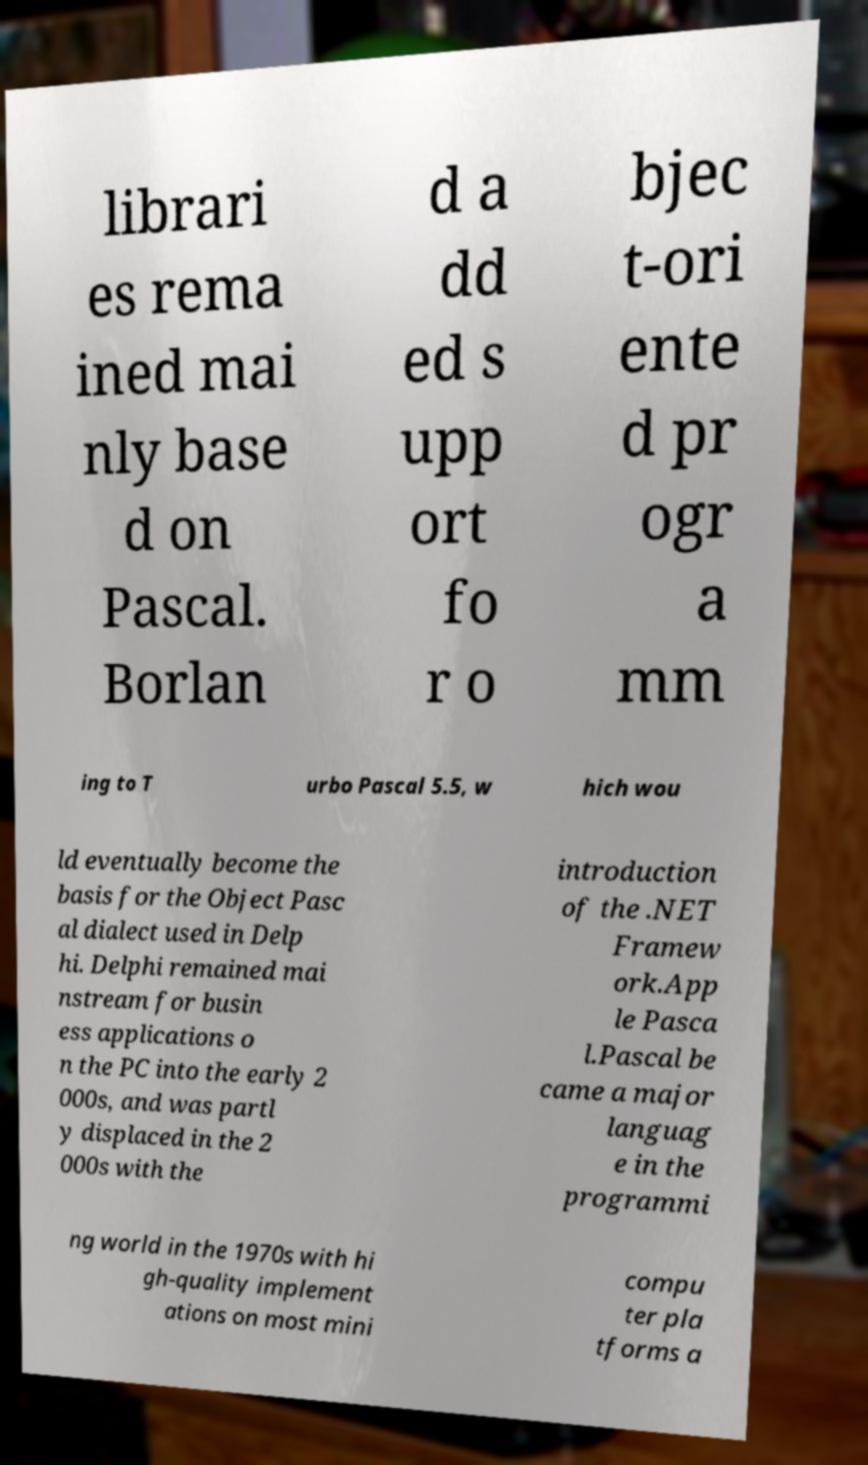Can you read and provide the text displayed in the image?This photo seems to have some interesting text. Can you extract and type it out for me? librari es rema ined mai nly base d on Pascal. Borlan d a dd ed s upp ort fo r o bjec t-ori ente d pr ogr a mm ing to T urbo Pascal 5.5, w hich wou ld eventually become the basis for the Object Pasc al dialect used in Delp hi. Delphi remained mai nstream for busin ess applications o n the PC into the early 2 000s, and was partl y displaced in the 2 000s with the introduction of the .NET Framew ork.App le Pasca l.Pascal be came a major languag e in the programmi ng world in the 1970s with hi gh-quality implement ations on most mini compu ter pla tforms a 